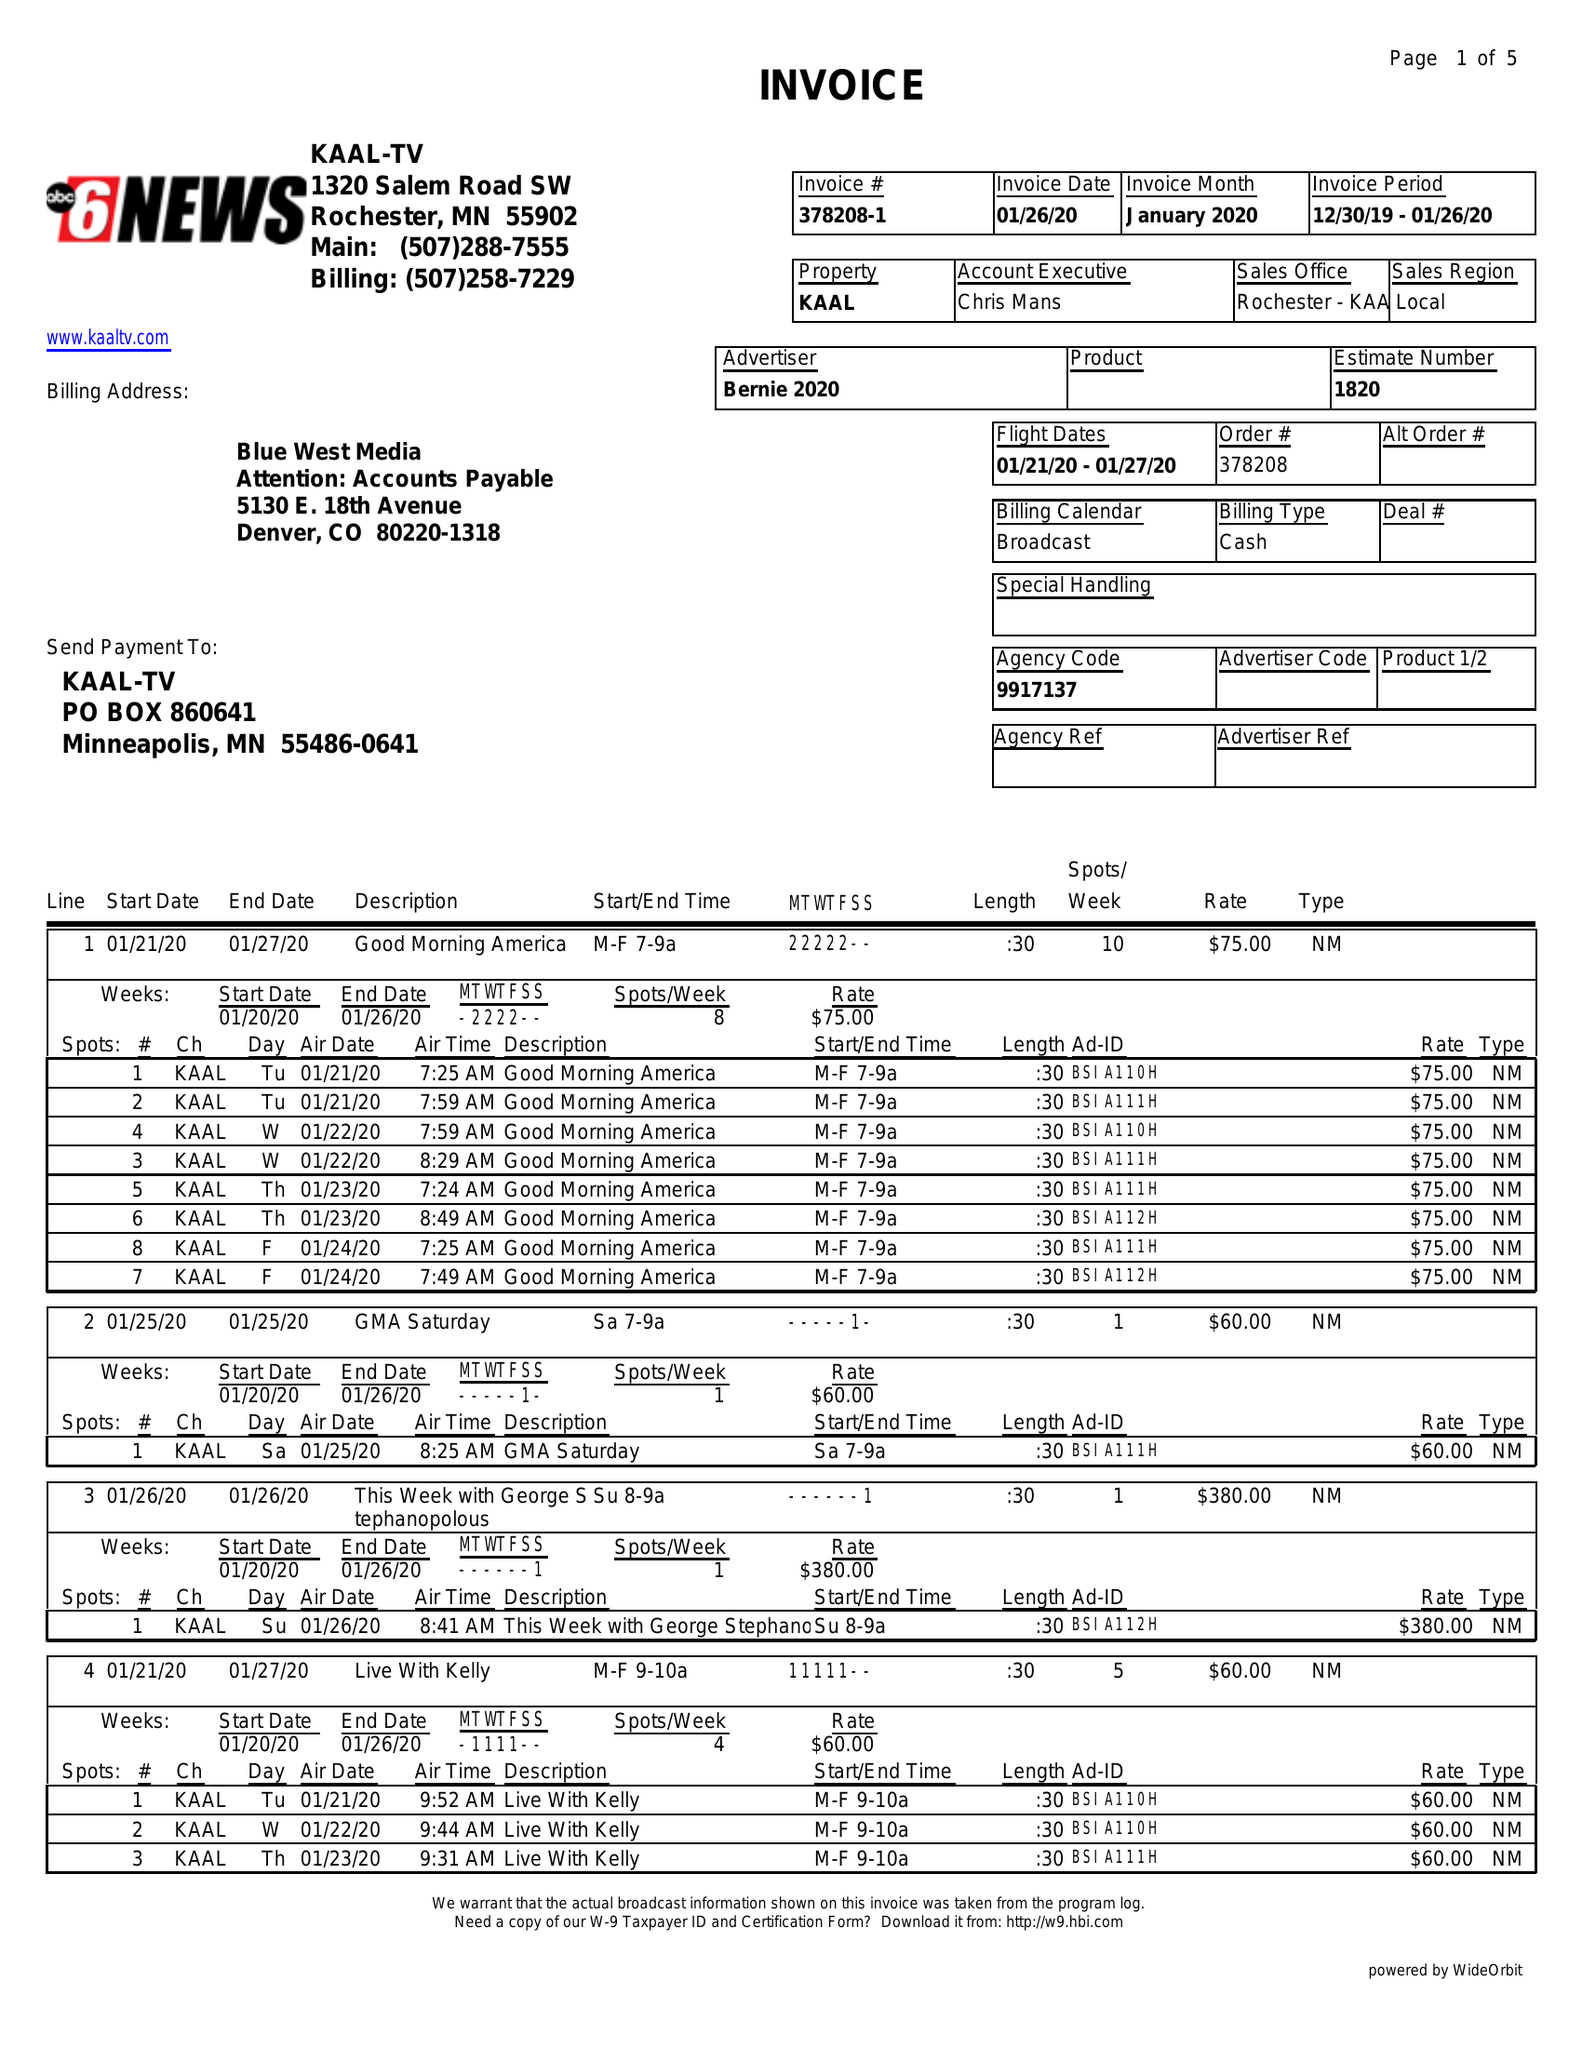What is the value for the flight_to?
Answer the question using a single word or phrase. 01/27/20 